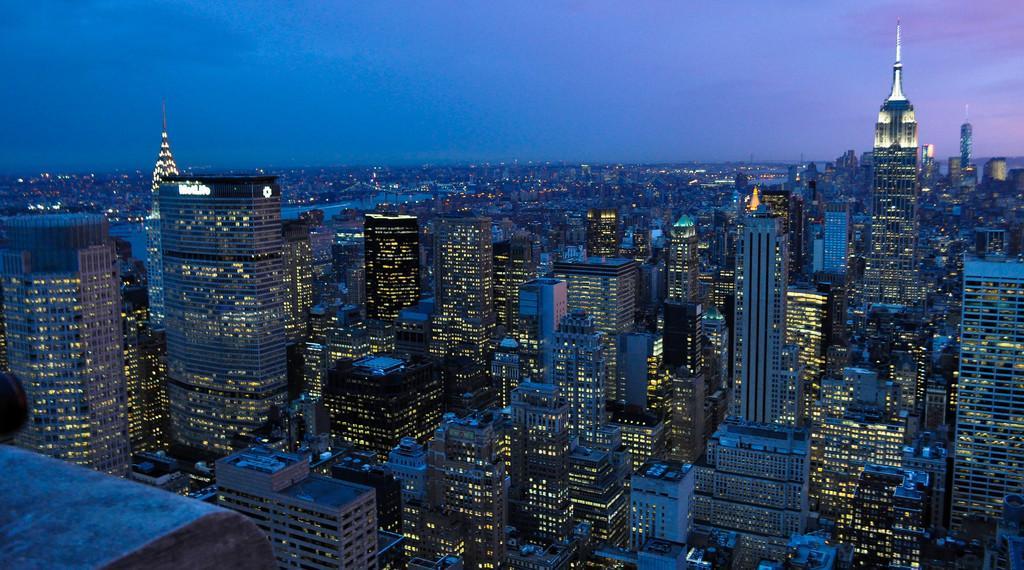Can you describe this image briefly? In this picture we can see few buildings and lights, and also we can see water. 